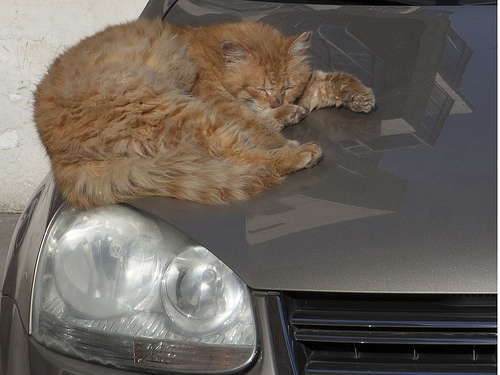<image>
Is the car on the cat? No. The car is not positioned on the cat. They may be near each other, but the car is not supported by or resting on top of the cat. 